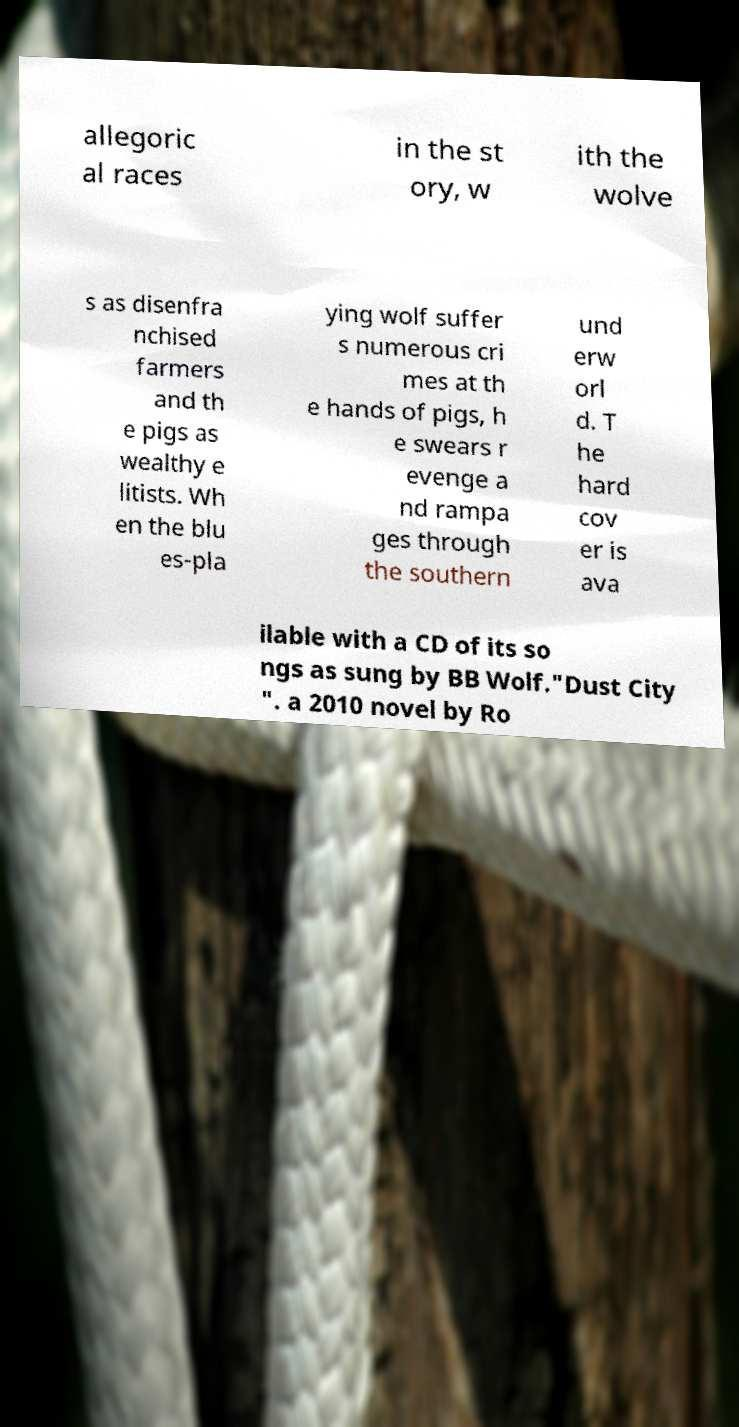Please identify and transcribe the text found in this image. allegoric al races in the st ory, w ith the wolve s as disenfra nchised farmers and th e pigs as wealthy e litists. Wh en the blu es-pla ying wolf suffer s numerous cri mes at th e hands of pigs, h e swears r evenge a nd rampa ges through the southern und erw orl d. T he hard cov er is ava ilable with a CD of its so ngs as sung by BB Wolf."Dust City ". a 2010 novel by Ro 